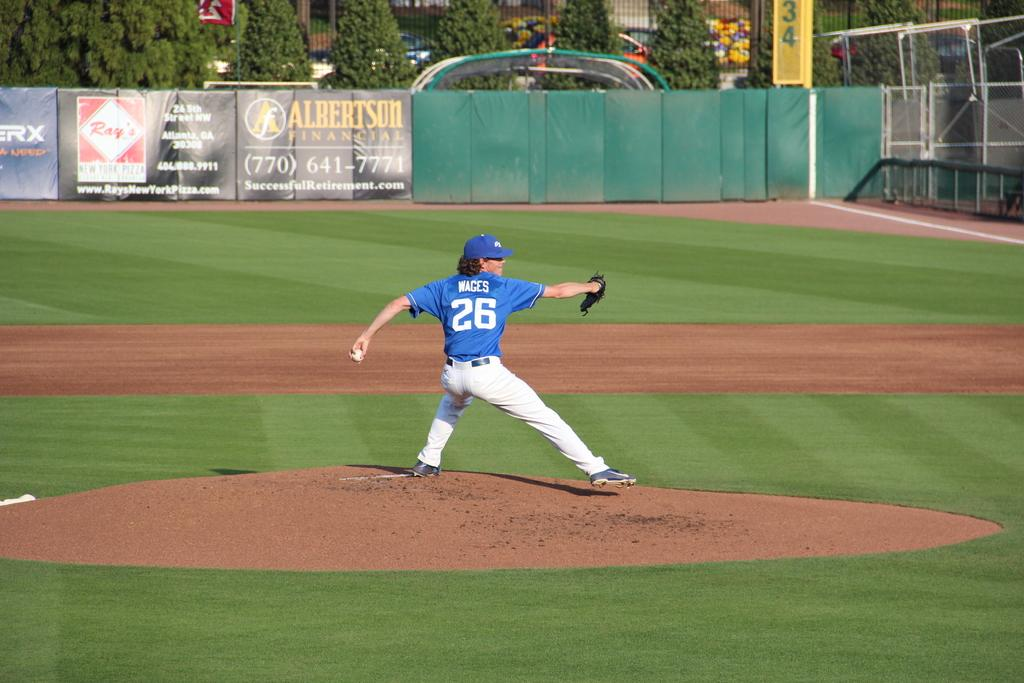<image>
Share a concise interpretation of the image provided. Pitcher number 26, Wages, winds up to throw a pitch during the baseball game. 